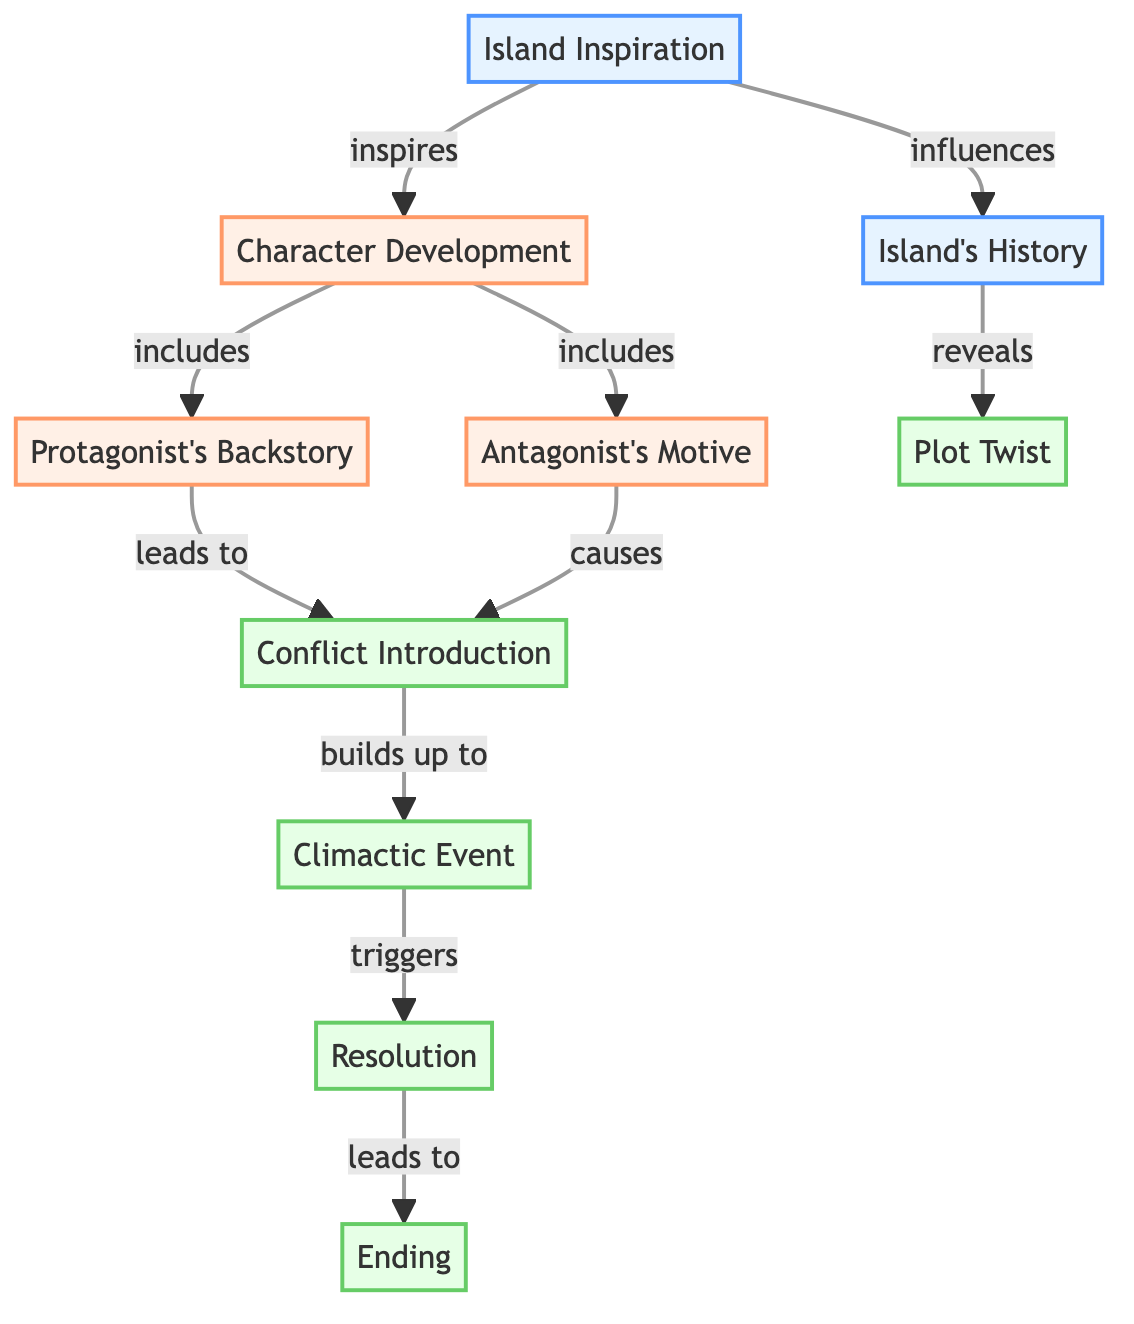What is the label of node 1? The diagram specifies that node 1 is labeled "Island Inspiration."
Answer: Island Inspiration How many nodes are in the diagram? The diagram presents 10 distinct nodes, as listed in the data section.
Answer: 10 What relationship exists between "Island Inspiration" and "Character Development"? The edge from node 1 to node 2 shows that "Island Inspiration" inspires "Character Development."
Answer: inspires Which node leads to the "Climactic Event"? Looking at the edges, the "Conflict Introduction" leads to the "Climactic Event." Therefore, the connecting node is 7.
Answer: 7 What does "Island's History" reveal? The edge from node 5 to node 6 indicates that "Island's History" reveals a "Plot Twist."
Answer: Plot Twist If the "Antagonist's Motive" causes a conflict, what leads to the resolution? The flow shows that after a conflict introduction (node 7), the next node is the "Climactic Event" (node 8), which triggers the "Resolution" (node 9), so the sequence is essential.
Answer: 9 How many edges connect the nodes? Counting the edges in the diagram, we find a total of 9 connections that link all the nodes.
Answer: 9 How does "Character Development" relate to "Protagonist's Backstory"? The diagram's edge indicates that "Character Development" includes "Protagonist's Backstory," showing a direct connection.
Answer: includes What is the final outcome after the resolution? According to the final edge from node 9 to node 10, the "Resolution" leads to the "Ending."
Answer: Ending 